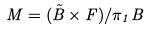<formula> <loc_0><loc_0><loc_500><loc_500>M = ( \tilde { B } \times F ) / \pi _ { 1 } B</formula> 